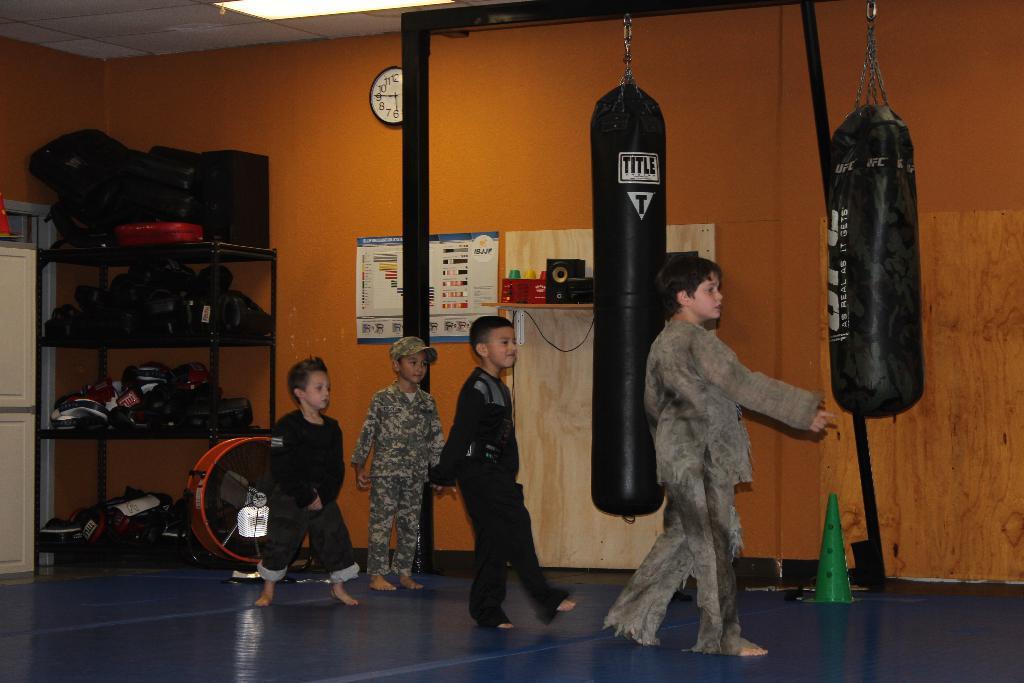In one or two sentences, can you explain what this image depicts? In this picture we can see children on the floor and in the background we can see a wall, clock, punching bags, poster and some objects. 